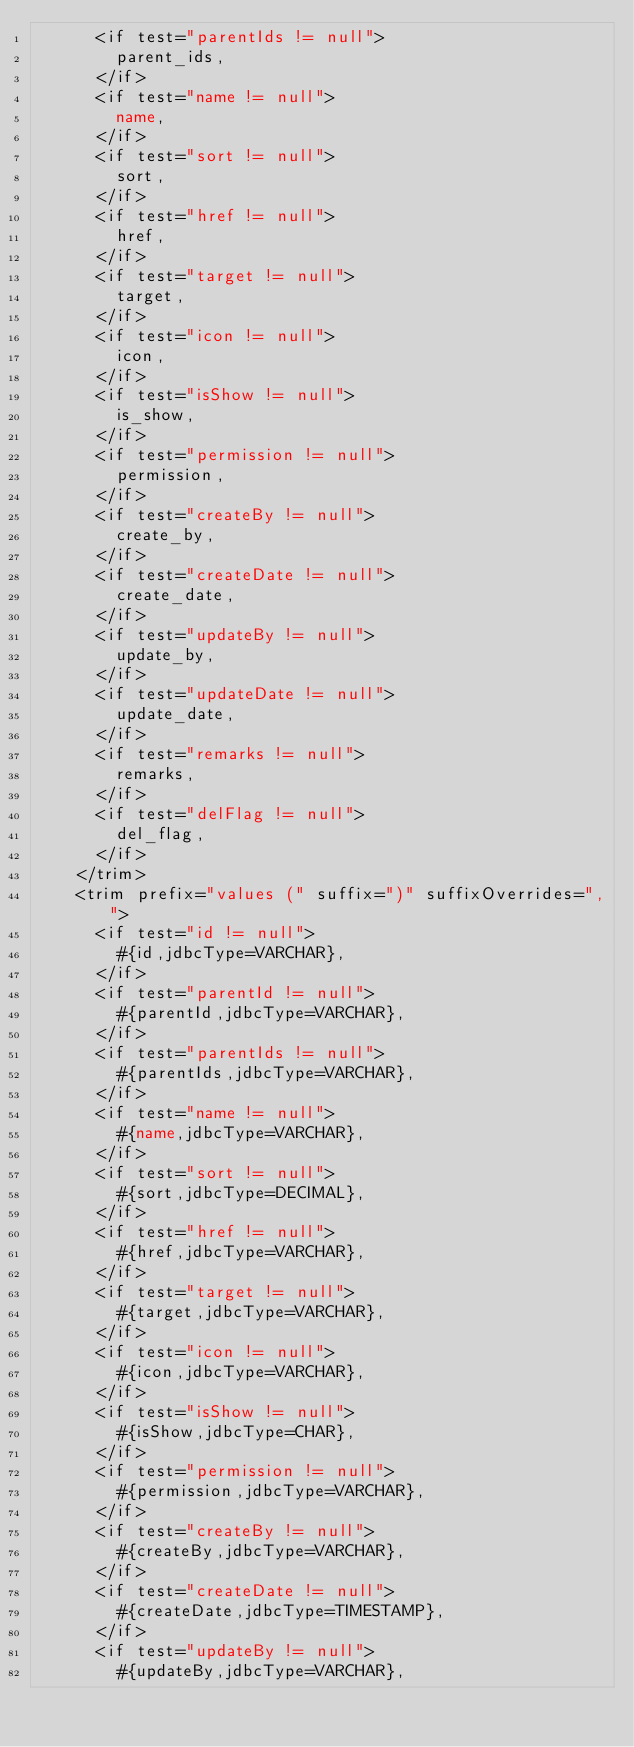Convert code to text. <code><loc_0><loc_0><loc_500><loc_500><_XML_>      <if test="parentIds != null">
        parent_ids,
      </if>
      <if test="name != null">
        name,
      </if>
      <if test="sort != null">
        sort,
      </if>
      <if test="href != null">
        href,
      </if>
      <if test="target != null">
        target,
      </if>
      <if test="icon != null">
        icon,
      </if>
      <if test="isShow != null">
        is_show,
      </if>
      <if test="permission != null">
        permission,
      </if>
      <if test="createBy != null">
        create_by,
      </if>
      <if test="createDate != null">
        create_date,
      </if>
      <if test="updateBy != null">
        update_by,
      </if>
      <if test="updateDate != null">
        update_date,
      </if>
      <if test="remarks != null">
        remarks,
      </if>
      <if test="delFlag != null">
        del_flag,
      </if>
    </trim>
    <trim prefix="values (" suffix=")" suffixOverrides=",">
      <if test="id != null">
        #{id,jdbcType=VARCHAR},
      </if>
      <if test="parentId != null">
        #{parentId,jdbcType=VARCHAR},
      </if>
      <if test="parentIds != null">
        #{parentIds,jdbcType=VARCHAR},
      </if>
      <if test="name != null">
        #{name,jdbcType=VARCHAR},
      </if>
      <if test="sort != null">
        #{sort,jdbcType=DECIMAL},
      </if>
      <if test="href != null">
        #{href,jdbcType=VARCHAR},
      </if>
      <if test="target != null">
        #{target,jdbcType=VARCHAR},
      </if>
      <if test="icon != null">
        #{icon,jdbcType=VARCHAR},
      </if>
      <if test="isShow != null">
        #{isShow,jdbcType=CHAR},
      </if>
      <if test="permission != null">
        #{permission,jdbcType=VARCHAR},
      </if>
      <if test="createBy != null">
        #{createBy,jdbcType=VARCHAR},
      </if>
      <if test="createDate != null">
        #{createDate,jdbcType=TIMESTAMP},
      </if>
      <if test="updateBy != null">
        #{updateBy,jdbcType=VARCHAR},</code> 